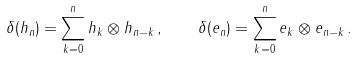Convert formula to latex. <formula><loc_0><loc_0><loc_500><loc_500>\delta ( h _ { n } ) = \sum _ { k = 0 } ^ { n } h _ { k } \otimes h _ { n - k } \, , \quad \delta ( e _ { n } ) = \sum _ { k = 0 } ^ { n } e _ { k } \otimes e _ { n - k } \, .</formula> 